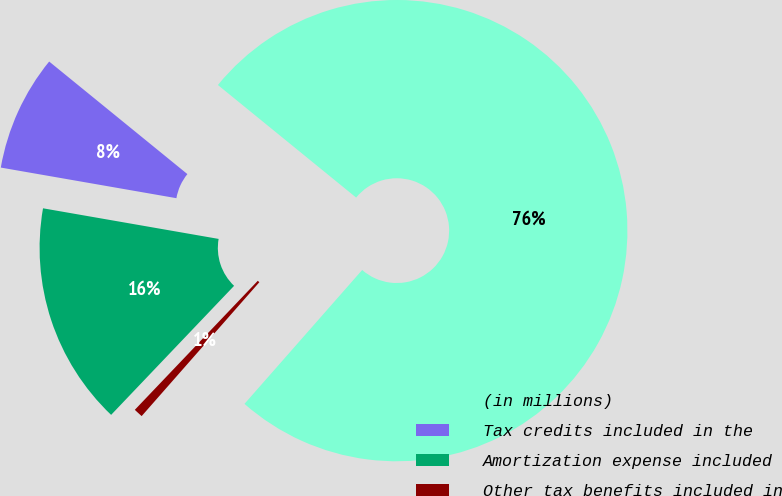<chart> <loc_0><loc_0><loc_500><loc_500><pie_chart><fcel>(in millions)<fcel>Tax credits included in the<fcel>Amortization expense included<fcel>Other tax benefits included in<nl><fcel>75.6%<fcel>8.13%<fcel>15.63%<fcel>0.64%<nl></chart> 